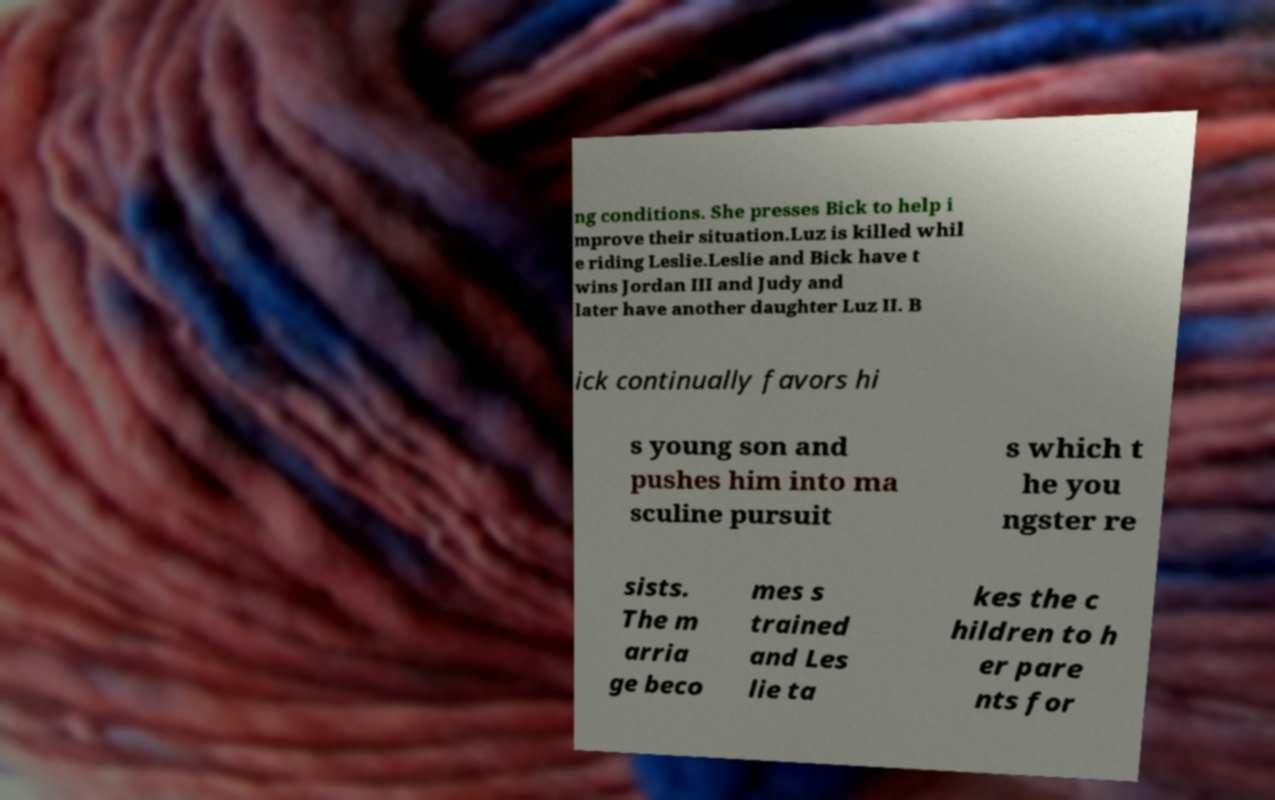Please read and relay the text visible in this image. What does it say? ng conditions. She presses Bick to help i mprove their situation.Luz is killed whil e riding Leslie.Leslie and Bick have t wins Jordan III and Judy and later have another daughter Luz II. B ick continually favors hi s young son and pushes him into ma sculine pursuit s which t he you ngster re sists. The m arria ge beco mes s trained and Les lie ta kes the c hildren to h er pare nts for 